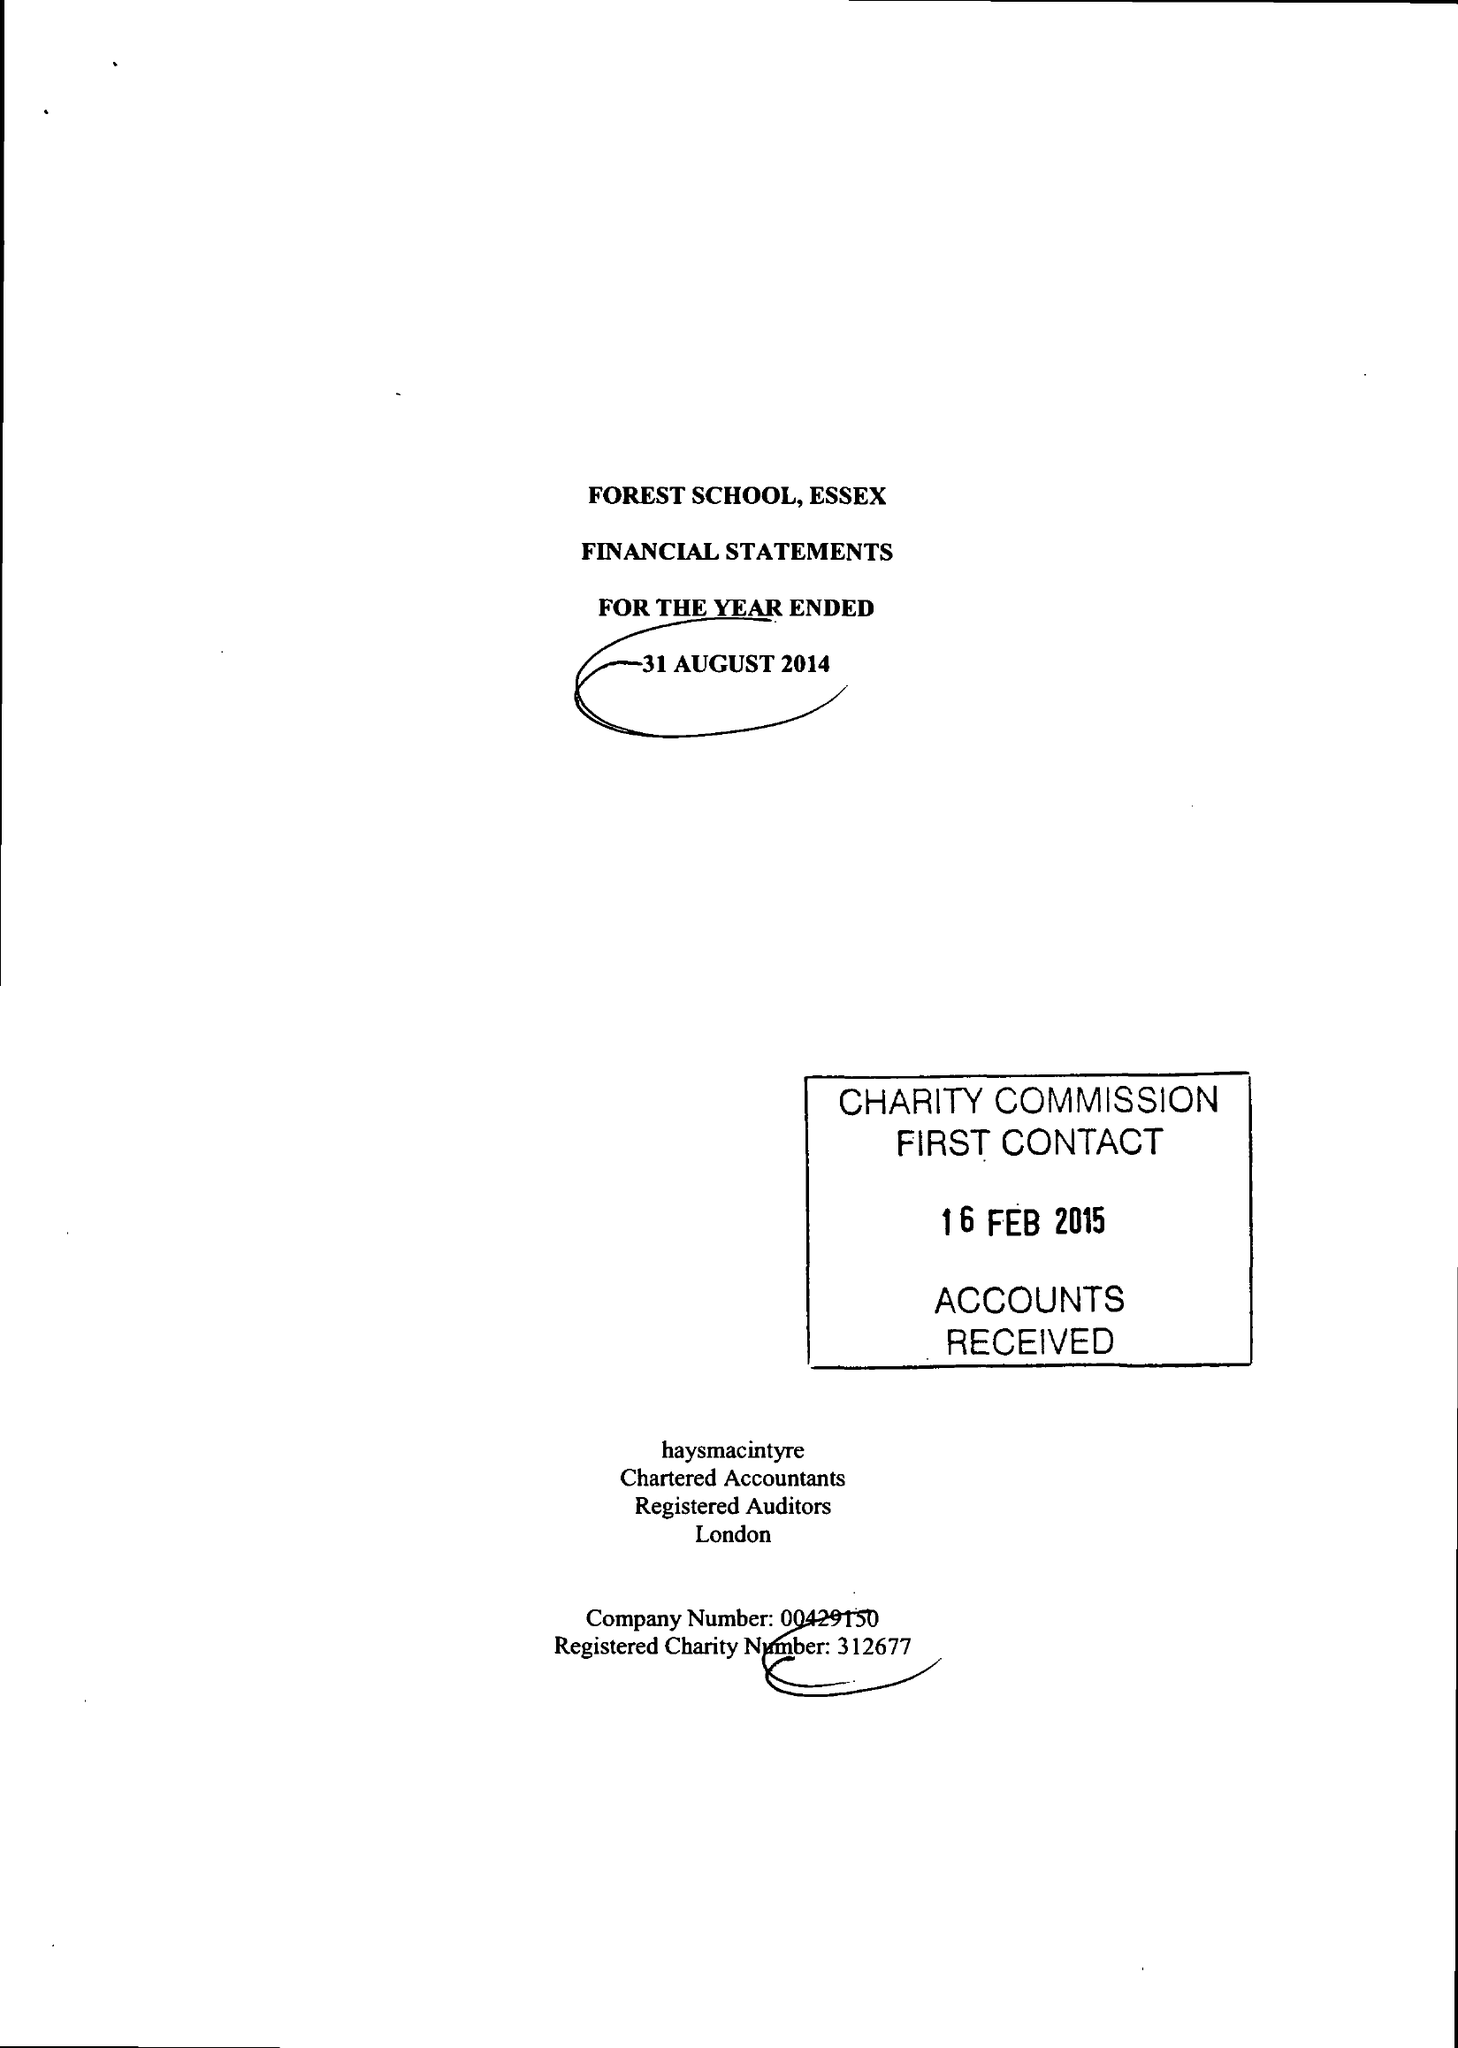What is the value for the report_date?
Answer the question using a single word or phrase. 2014-08-31 